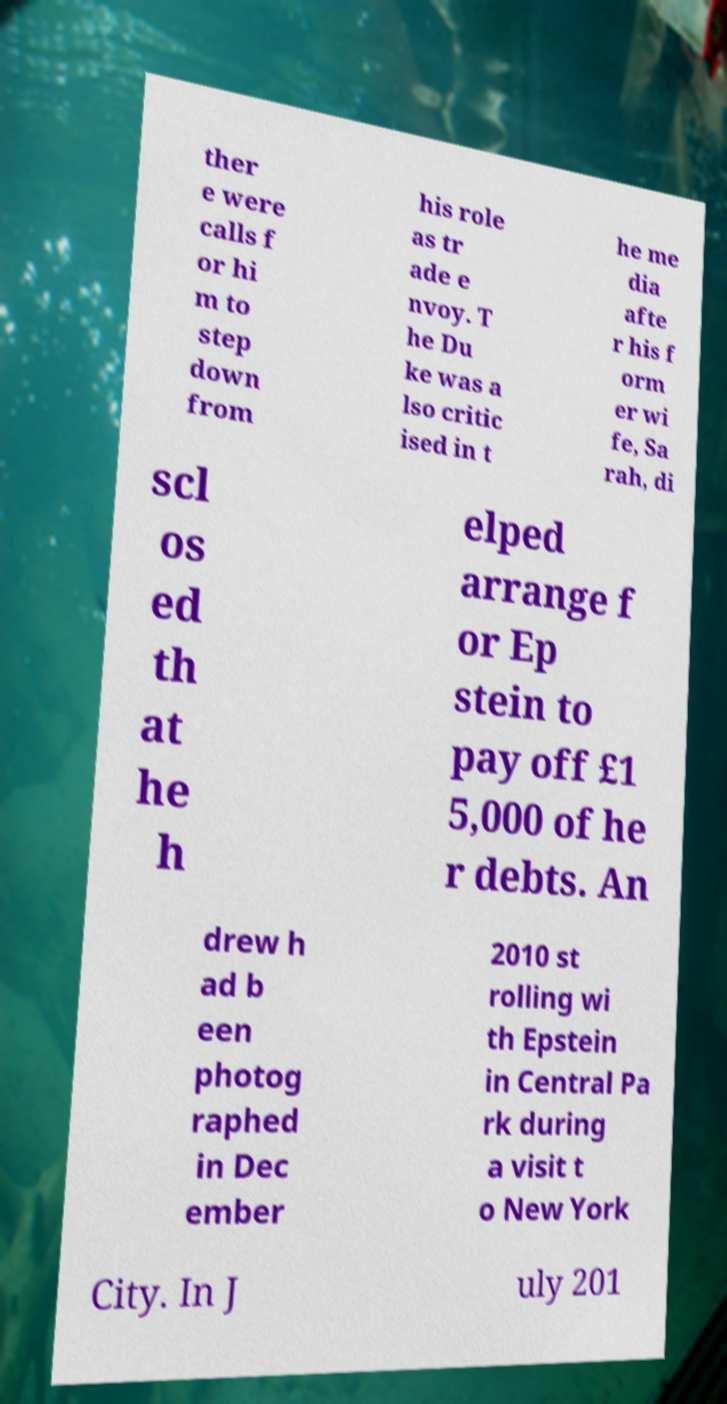Can you read and provide the text displayed in the image?This photo seems to have some interesting text. Can you extract and type it out for me? ther e were calls f or hi m to step down from his role as tr ade e nvoy. T he Du ke was a lso critic ised in t he me dia afte r his f orm er wi fe, Sa rah, di scl os ed th at he h elped arrange f or Ep stein to pay off £1 5,000 of he r debts. An drew h ad b een photog raphed in Dec ember 2010 st rolling wi th Epstein in Central Pa rk during a visit t o New York City. In J uly 201 